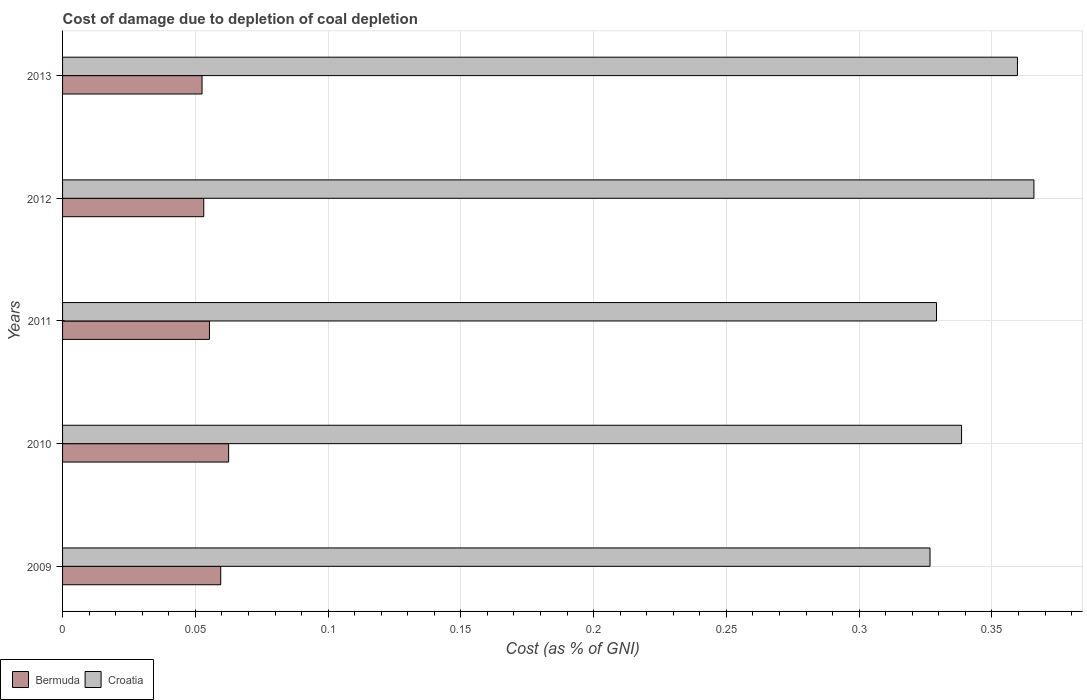How many different coloured bars are there?
Your answer should be compact. 2. How many groups of bars are there?
Provide a short and direct response. 5. Are the number of bars on each tick of the Y-axis equal?
Give a very brief answer. Yes. How many bars are there on the 5th tick from the top?
Provide a succinct answer. 2. What is the cost of damage caused due to coal depletion in Croatia in 2010?
Provide a short and direct response. 0.34. Across all years, what is the maximum cost of damage caused due to coal depletion in Croatia?
Your answer should be compact. 0.37. Across all years, what is the minimum cost of damage caused due to coal depletion in Croatia?
Offer a very short reply. 0.33. What is the total cost of damage caused due to coal depletion in Croatia in the graph?
Make the answer very short. 1.72. What is the difference between the cost of damage caused due to coal depletion in Croatia in 2010 and that in 2012?
Your response must be concise. -0.03. What is the difference between the cost of damage caused due to coal depletion in Croatia in 2009 and the cost of damage caused due to coal depletion in Bermuda in 2012?
Provide a succinct answer. 0.27. What is the average cost of damage caused due to coal depletion in Bermuda per year?
Keep it short and to the point. 0.06. In the year 2009, what is the difference between the cost of damage caused due to coal depletion in Bermuda and cost of damage caused due to coal depletion in Croatia?
Provide a short and direct response. -0.27. What is the ratio of the cost of damage caused due to coal depletion in Bermuda in 2009 to that in 2012?
Your response must be concise. 1.12. Is the difference between the cost of damage caused due to coal depletion in Bermuda in 2010 and 2013 greater than the difference between the cost of damage caused due to coal depletion in Croatia in 2010 and 2013?
Provide a succinct answer. Yes. What is the difference between the highest and the second highest cost of damage caused due to coal depletion in Bermuda?
Your answer should be very brief. 0. What is the difference between the highest and the lowest cost of damage caused due to coal depletion in Croatia?
Ensure brevity in your answer.  0.04. In how many years, is the cost of damage caused due to coal depletion in Bermuda greater than the average cost of damage caused due to coal depletion in Bermuda taken over all years?
Provide a short and direct response. 2. Is the sum of the cost of damage caused due to coal depletion in Croatia in 2009 and 2012 greater than the maximum cost of damage caused due to coal depletion in Bermuda across all years?
Offer a terse response. Yes. What does the 1st bar from the top in 2009 represents?
Ensure brevity in your answer.  Croatia. What does the 1st bar from the bottom in 2011 represents?
Provide a short and direct response. Bermuda. How many bars are there?
Your answer should be very brief. 10. How many years are there in the graph?
Make the answer very short. 5. Are the values on the major ticks of X-axis written in scientific E-notation?
Ensure brevity in your answer.  No. Does the graph contain any zero values?
Make the answer very short. No. Where does the legend appear in the graph?
Give a very brief answer. Bottom left. How many legend labels are there?
Give a very brief answer. 2. How are the legend labels stacked?
Give a very brief answer. Horizontal. What is the title of the graph?
Keep it short and to the point. Cost of damage due to depletion of coal depletion. What is the label or title of the X-axis?
Make the answer very short. Cost (as % of GNI). What is the Cost (as % of GNI) of Bermuda in 2009?
Your answer should be compact. 0.06. What is the Cost (as % of GNI) of Croatia in 2009?
Ensure brevity in your answer.  0.33. What is the Cost (as % of GNI) in Bermuda in 2010?
Ensure brevity in your answer.  0.06. What is the Cost (as % of GNI) of Croatia in 2010?
Provide a succinct answer. 0.34. What is the Cost (as % of GNI) in Bermuda in 2011?
Make the answer very short. 0.06. What is the Cost (as % of GNI) of Croatia in 2011?
Make the answer very short. 0.33. What is the Cost (as % of GNI) in Bermuda in 2012?
Offer a terse response. 0.05. What is the Cost (as % of GNI) of Croatia in 2012?
Offer a very short reply. 0.37. What is the Cost (as % of GNI) of Bermuda in 2013?
Offer a very short reply. 0.05. What is the Cost (as % of GNI) of Croatia in 2013?
Your answer should be compact. 0.36. Across all years, what is the maximum Cost (as % of GNI) in Bermuda?
Offer a very short reply. 0.06. Across all years, what is the maximum Cost (as % of GNI) in Croatia?
Your answer should be compact. 0.37. Across all years, what is the minimum Cost (as % of GNI) of Bermuda?
Offer a very short reply. 0.05. Across all years, what is the minimum Cost (as % of GNI) in Croatia?
Your answer should be compact. 0.33. What is the total Cost (as % of GNI) in Bermuda in the graph?
Ensure brevity in your answer.  0.28. What is the total Cost (as % of GNI) of Croatia in the graph?
Provide a succinct answer. 1.72. What is the difference between the Cost (as % of GNI) of Bermuda in 2009 and that in 2010?
Offer a terse response. -0. What is the difference between the Cost (as % of GNI) in Croatia in 2009 and that in 2010?
Offer a very short reply. -0.01. What is the difference between the Cost (as % of GNI) of Bermuda in 2009 and that in 2011?
Give a very brief answer. 0. What is the difference between the Cost (as % of GNI) in Croatia in 2009 and that in 2011?
Your answer should be compact. -0. What is the difference between the Cost (as % of GNI) of Bermuda in 2009 and that in 2012?
Your answer should be very brief. 0.01. What is the difference between the Cost (as % of GNI) of Croatia in 2009 and that in 2012?
Provide a short and direct response. -0.04. What is the difference between the Cost (as % of GNI) of Bermuda in 2009 and that in 2013?
Your answer should be very brief. 0.01. What is the difference between the Cost (as % of GNI) of Croatia in 2009 and that in 2013?
Give a very brief answer. -0.03. What is the difference between the Cost (as % of GNI) of Bermuda in 2010 and that in 2011?
Offer a terse response. 0.01. What is the difference between the Cost (as % of GNI) of Croatia in 2010 and that in 2011?
Provide a short and direct response. 0.01. What is the difference between the Cost (as % of GNI) in Bermuda in 2010 and that in 2012?
Offer a very short reply. 0.01. What is the difference between the Cost (as % of GNI) of Croatia in 2010 and that in 2012?
Provide a succinct answer. -0.03. What is the difference between the Cost (as % of GNI) in Croatia in 2010 and that in 2013?
Your response must be concise. -0.02. What is the difference between the Cost (as % of GNI) of Bermuda in 2011 and that in 2012?
Keep it short and to the point. 0. What is the difference between the Cost (as % of GNI) of Croatia in 2011 and that in 2012?
Make the answer very short. -0.04. What is the difference between the Cost (as % of GNI) in Bermuda in 2011 and that in 2013?
Provide a short and direct response. 0. What is the difference between the Cost (as % of GNI) of Croatia in 2011 and that in 2013?
Keep it short and to the point. -0.03. What is the difference between the Cost (as % of GNI) in Bermuda in 2012 and that in 2013?
Give a very brief answer. 0. What is the difference between the Cost (as % of GNI) of Croatia in 2012 and that in 2013?
Offer a terse response. 0.01. What is the difference between the Cost (as % of GNI) of Bermuda in 2009 and the Cost (as % of GNI) of Croatia in 2010?
Your answer should be very brief. -0.28. What is the difference between the Cost (as % of GNI) in Bermuda in 2009 and the Cost (as % of GNI) in Croatia in 2011?
Offer a very short reply. -0.27. What is the difference between the Cost (as % of GNI) of Bermuda in 2009 and the Cost (as % of GNI) of Croatia in 2012?
Ensure brevity in your answer.  -0.31. What is the difference between the Cost (as % of GNI) in Bermuda in 2009 and the Cost (as % of GNI) in Croatia in 2013?
Give a very brief answer. -0.3. What is the difference between the Cost (as % of GNI) in Bermuda in 2010 and the Cost (as % of GNI) in Croatia in 2011?
Keep it short and to the point. -0.27. What is the difference between the Cost (as % of GNI) in Bermuda in 2010 and the Cost (as % of GNI) in Croatia in 2012?
Your answer should be very brief. -0.3. What is the difference between the Cost (as % of GNI) of Bermuda in 2010 and the Cost (as % of GNI) of Croatia in 2013?
Your response must be concise. -0.3. What is the difference between the Cost (as % of GNI) in Bermuda in 2011 and the Cost (as % of GNI) in Croatia in 2012?
Your answer should be very brief. -0.31. What is the difference between the Cost (as % of GNI) of Bermuda in 2011 and the Cost (as % of GNI) of Croatia in 2013?
Provide a succinct answer. -0.3. What is the difference between the Cost (as % of GNI) in Bermuda in 2012 and the Cost (as % of GNI) in Croatia in 2013?
Give a very brief answer. -0.31. What is the average Cost (as % of GNI) of Bermuda per year?
Give a very brief answer. 0.06. What is the average Cost (as % of GNI) of Croatia per year?
Your answer should be very brief. 0.34. In the year 2009, what is the difference between the Cost (as % of GNI) in Bermuda and Cost (as % of GNI) in Croatia?
Provide a short and direct response. -0.27. In the year 2010, what is the difference between the Cost (as % of GNI) in Bermuda and Cost (as % of GNI) in Croatia?
Your answer should be very brief. -0.28. In the year 2011, what is the difference between the Cost (as % of GNI) in Bermuda and Cost (as % of GNI) in Croatia?
Provide a succinct answer. -0.27. In the year 2012, what is the difference between the Cost (as % of GNI) in Bermuda and Cost (as % of GNI) in Croatia?
Give a very brief answer. -0.31. In the year 2013, what is the difference between the Cost (as % of GNI) of Bermuda and Cost (as % of GNI) of Croatia?
Offer a terse response. -0.31. What is the ratio of the Cost (as % of GNI) in Bermuda in 2009 to that in 2010?
Your answer should be very brief. 0.95. What is the ratio of the Cost (as % of GNI) in Croatia in 2009 to that in 2010?
Ensure brevity in your answer.  0.96. What is the ratio of the Cost (as % of GNI) of Croatia in 2009 to that in 2011?
Provide a short and direct response. 0.99. What is the ratio of the Cost (as % of GNI) in Bermuda in 2009 to that in 2012?
Your answer should be compact. 1.12. What is the ratio of the Cost (as % of GNI) of Croatia in 2009 to that in 2012?
Ensure brevity in your answer.  0.89. What is the ratio of the Cost (as % of GNI) in Bermuda in 2009 to that in 2013?
Give a very brief answer. 1.13. What is the ratio of the Cost (as % of GNI) in Croatia in 2009 to that in 2013?
Your answer should be compact. 0.91. What is the ratio of the Cost (as % of GNI) of Bermuda in 2010 to that in 2011?
Make the answer very short. 1.13. What is the ratio of the Cost (as % of GNI) in Croatia in 2010 to that in 2011?
Your response must be concise. 1.03. What is the ratio of the Cost (as % of GNI) of Bermuda in 2010 to that in 2012?
Ensure brevity in your answer.  1.18. What is the ratio of the Cost (as % of GNI) in Croatia in 2010 to that in 2012?
Ensure brevity in your answer.  0.93. What is the ratio of the Cost (as % of GNI) of Bermuda in 2010 to that in 2013?
Provide a succinct answer. 1.19. What is the ratio of the Cost (as % of GNI) in Croatia in 2010 to that in 2013?
Provide a succinct answer. 0.94. What is the ratio of the Cost (as % of GNI) of Bermuda in 2011 to that in 2012?
Ensure brevity in your answer.  1.04. What is the ratio of the Cost (as % of GNI) in Croatia in 2011 to that in 2012?
Provide a succinct answer. 0.9. What is the ratio of the Cost (as % of GNI) of Bermuda in 2011 to that in 2013?
Offer a very short reply. 1.05. What is the ratio of the Cost (as % of GNI) of Croatia in 2011 to that in 2013?
Ensure brevity in your answer.  0.92. What is the ratio of the Cost (as % of GNI) of Bermuda in 2012 to that in 2013?
Offer a very short reply. 1.01. What is the ratio of the Cost (as % of GNI) of Croatia in 2012 to that in 2013?
Make the answer very short. 1.02. What is the difference between the highest and the second highest Cost (as % of GNI) in Bermuda?
Your answer should be very brief. 0. What is the difference between the highest and the second highest Cost (as % of GNI) in Croatia?
Your answer should be compact. 0.01. What is the difference between the highest and the lowest Cost (as % of GNI) in Bermuda?
Make the answer very short. 0.01. What is the difference between the highest and the lowest Cost (as % of GNI) in Croatia?
Your answer should be very brief. 0.04. 